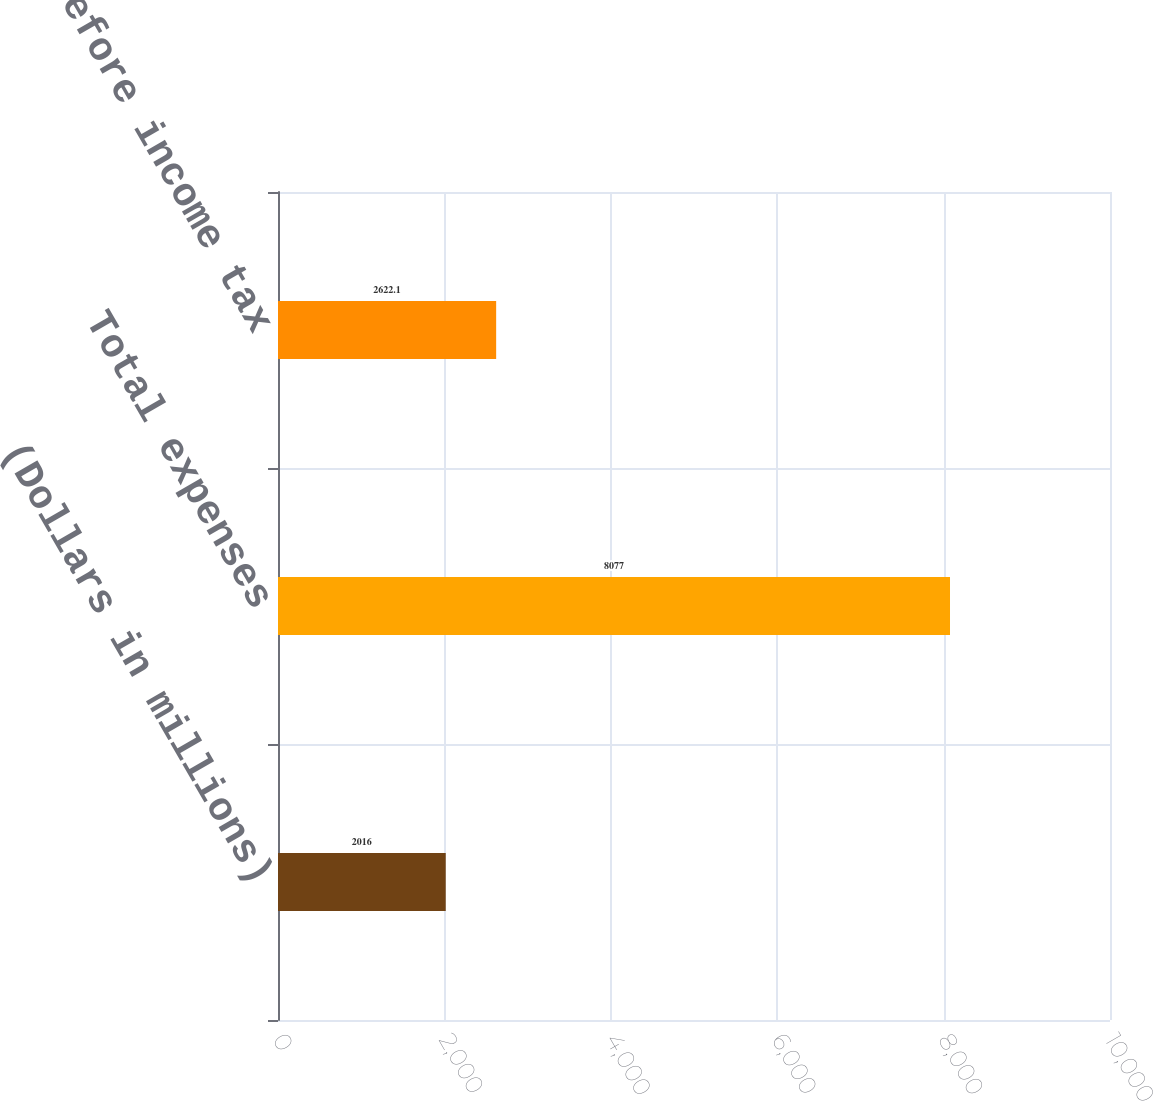Convert chart to OTSL. <chart><loc_0><loc_0><loc_500><loc_500><bar_chart><fcel>(Dollars in millions)<fcel>Total expenses<fcel>Income before income tax<nl><fcel>2016<fcel>8077<fcel>2622.1<nl></chart> 